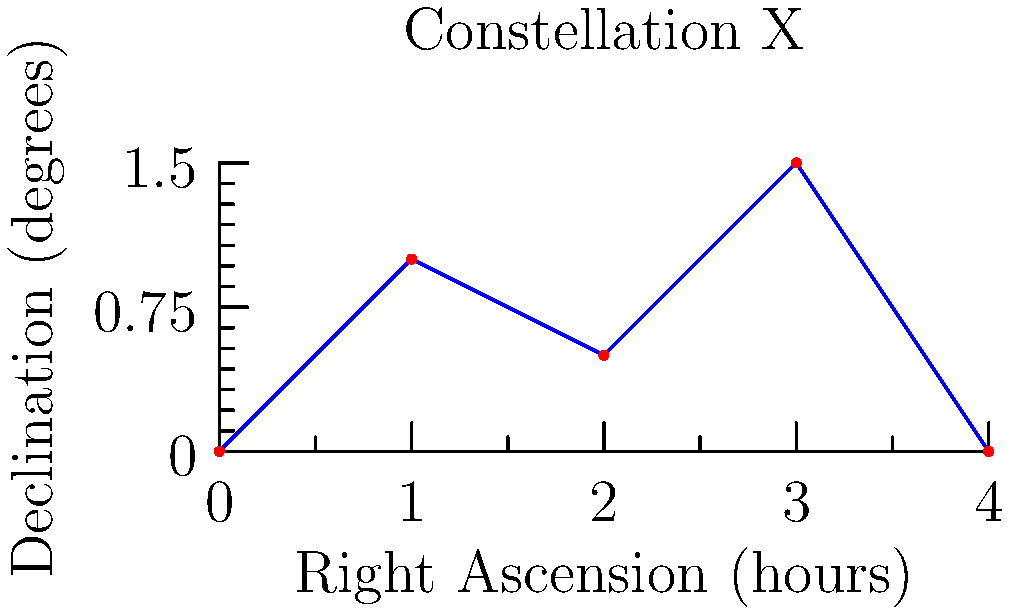Given the star constellation shown in the figure, write a MATLAB function that takes the Right Ascension (RA) and Declination (Dec) coordinates of the stars as input and plots the constellation. The function should also connect the stars with lines in the order they are given. How would you implement this function? To implement this function in MATLAB, we can follow these steps:

1. Define the function with input parameters for RA and Dec:
   ```matlab
   function plot_constellation(RA, Dec)
   ```

2. Create a new figure:
   ```matlab
   figure;
   ```

3. Plot the stars using the `scatter` function:
   ```matlab
   scatter(RA, Dec, 50, 'r', 'filled');
   ```

4. Connect the stars with lines using the `line` function:
   ```matlab
   line(RA, Dec, 'Color', 'b');
   ```

5. Set the axis labels and title:
   ```matlab
   xlabel('Right Ascension (hours)');
   ylabel('Declination (degrees)');
   title('Star Constellation');
   ```

6. Optionally, adjust the axis limits and aspect ratio:
   ```matlab
   axis([min(RA)-0.5, max(RA)+0.5, min(Dec)-0.5, max(Dec)+0.5]);
   axis equal;
   ```

The complete MATLAB function would look like this:

```matlab
function plot_constellation(RA, Dec)
    figure;
    scatter(RA, Dec, 50, 'r', 'filled');
    hold on;
    line(RA, Dec, 'Color', 'b');
    xlabel('Right Ascension (hours)');
    ylabel('Declination (degrees)');
    title('Star Constellation');
    axis([min(RA)-0.5, max(RA)+0.5, min(Dec)-0.5, max(Dec)+0.5]);
    axis equal;
end
```

To use this function, you would call it with the RA and Dec coordinates of the stars:

```matlab
RA = [0, 1, 2, 3, 4];
Dec = [0, 1, 0.5, 1.5, 0];
plot_constellation(RA, Dec);
```

This implementation allows for easy visualization of any star constellation given its coordinates.
Answer: plot_constellation(RA, Dec) 